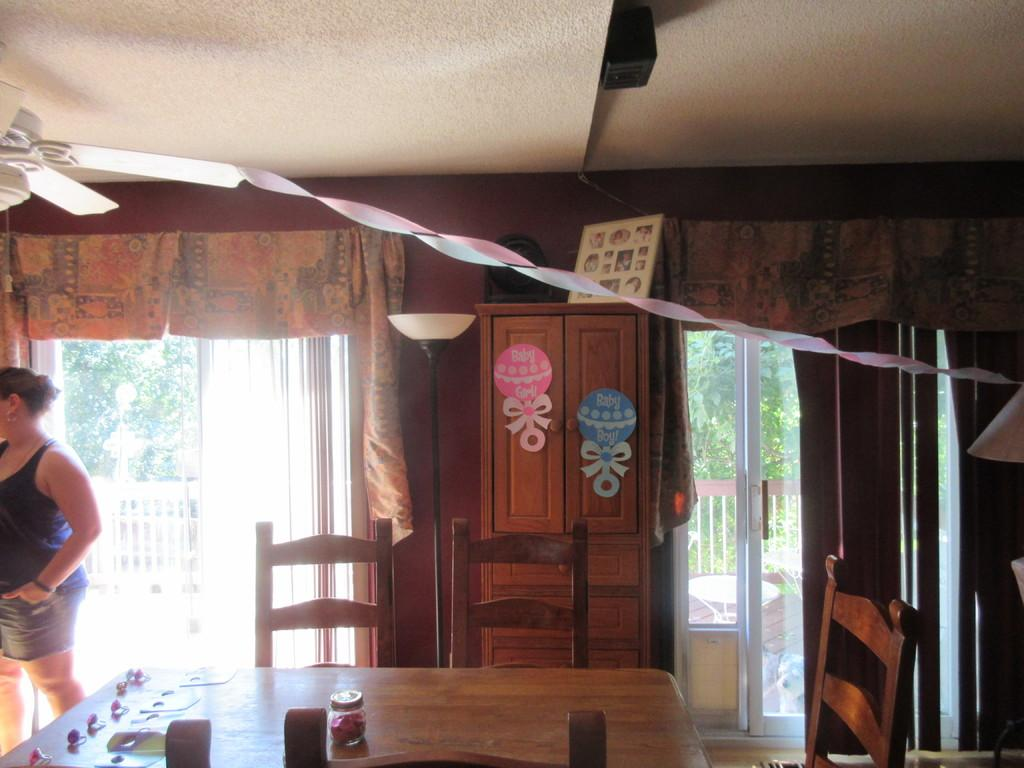What piece of furniture is present in the image? There is a table in the image. What is on top of the table? There are objects on the table. What type of seating is available around the table? There are chairs around the table. Can you describe the woman in the image? There is a woman standing in the left corner of the image. What type of jam is being served on the table in the image? There is no jam present on the table in the image. What nation does the woman in the image represent? The image does not provide information about the woman's nationality, so it cannot be determined. 